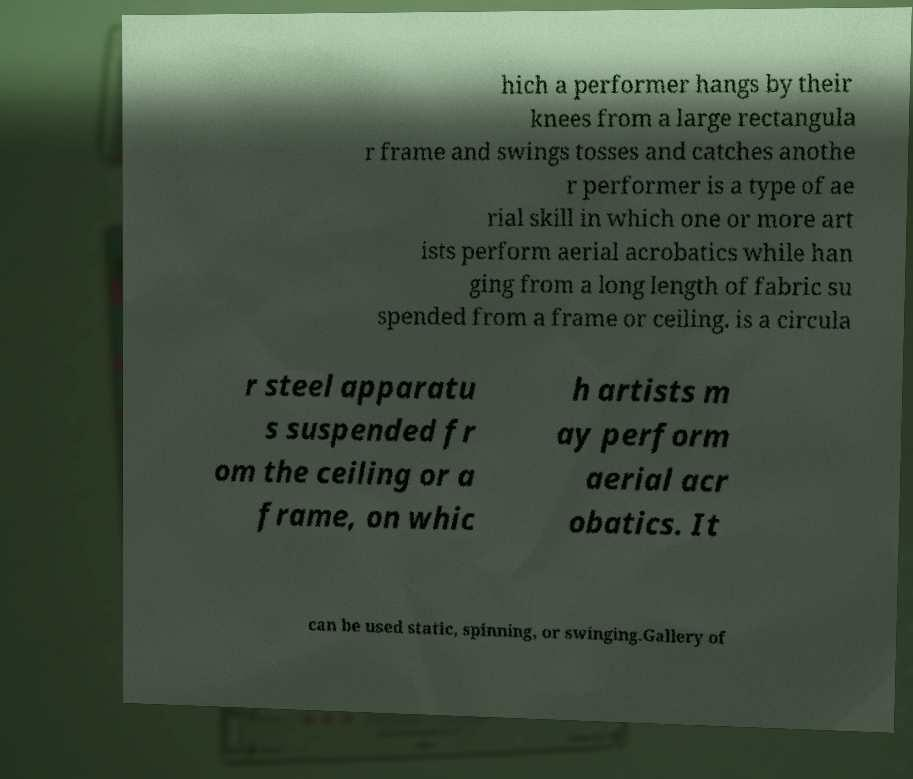Please read and relay the text visible in this image. What does it say? hich a performer hangs by their knees from a large rectangula r frame and swings tosses and catches anothe r performer is a type of ae rial skill in which one or more art ists perform aerial acrobatics while han ging from a long length of fabric su spended from a frame or ceiling. is a circula r steel apparatu s suspended fr om the ceiling or a frame, on whic h artists m ay perform aerial acr obatics. It can be used static, spinning, or swinging.Gallery of 